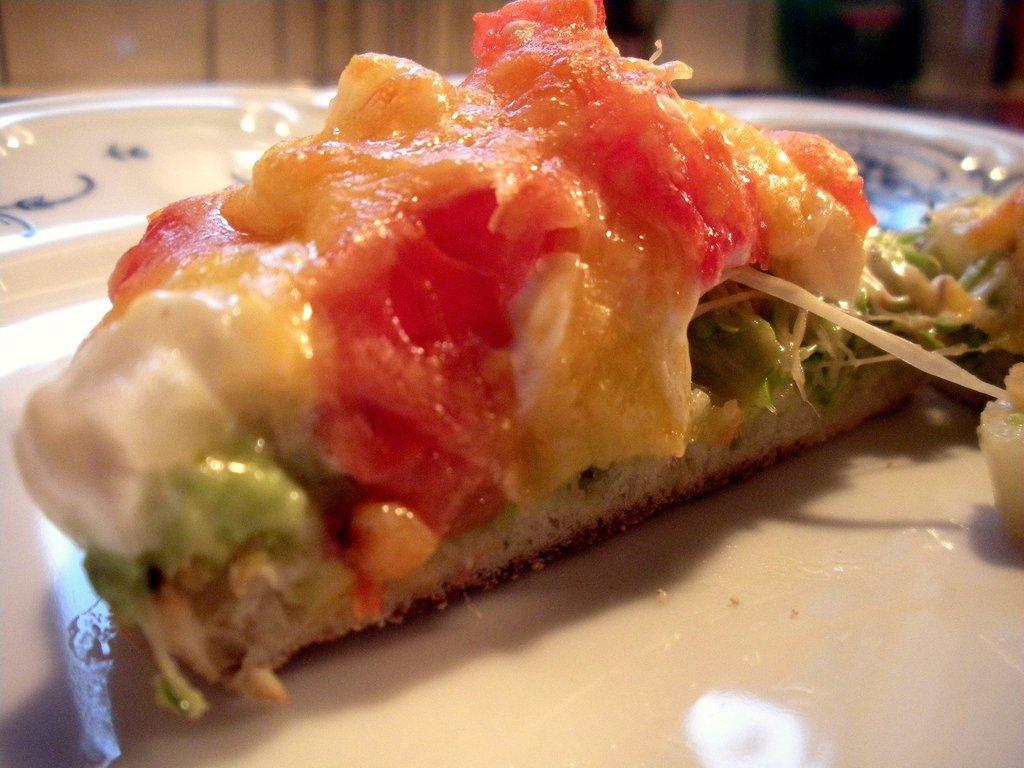In one or two sentences, can you explain what this image depicts? This picture shows food in the plate. 